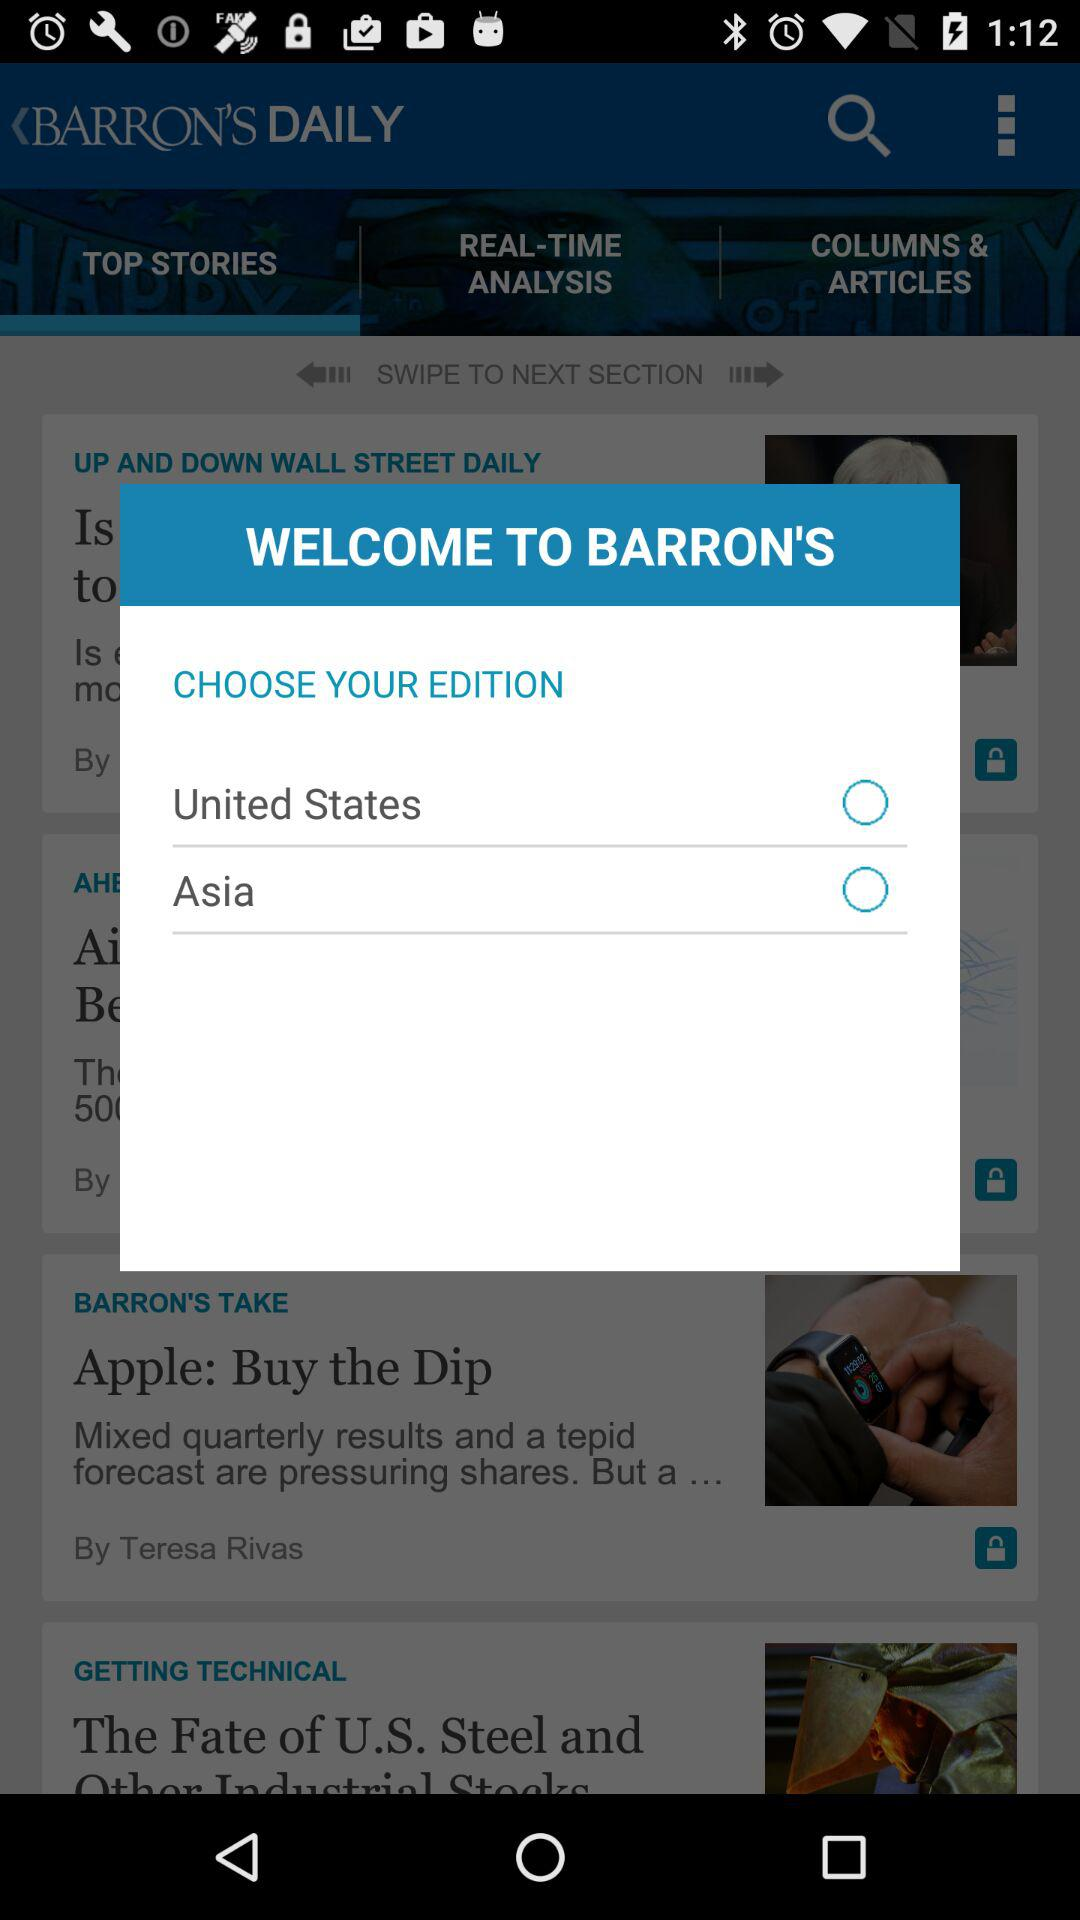Who posted the story "Apple: Buy the Dip"? The story "Apple: Buy the Dip" was posted by Teresa Rivas. 